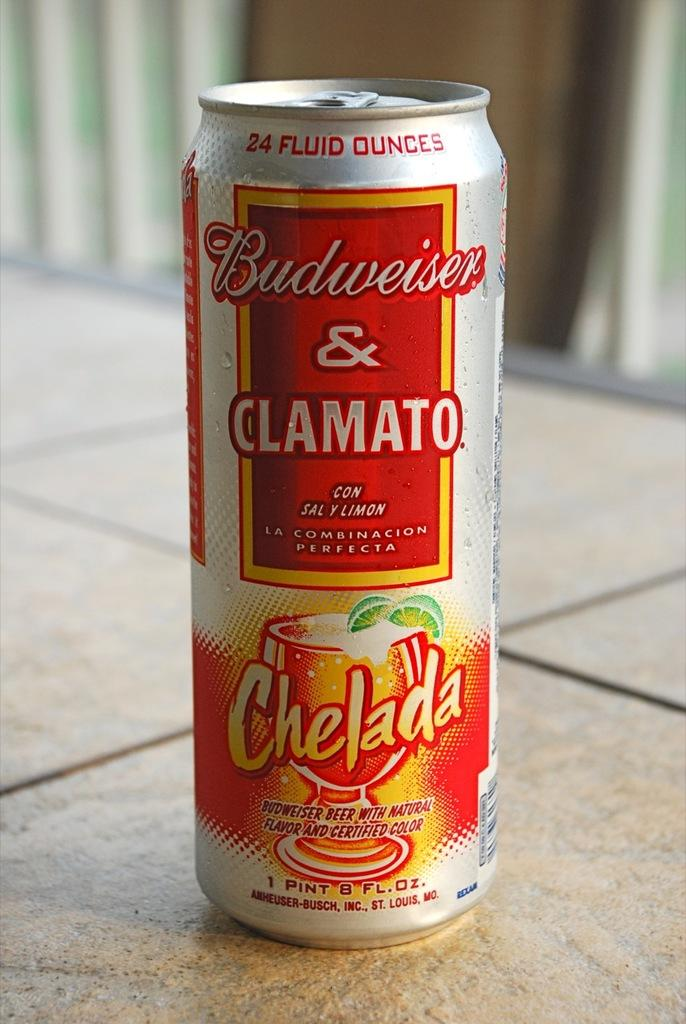<image>
Render a clear and concise summary of the photo. A tin budweiser and clamato chelada branded beer on a wooden surface. 